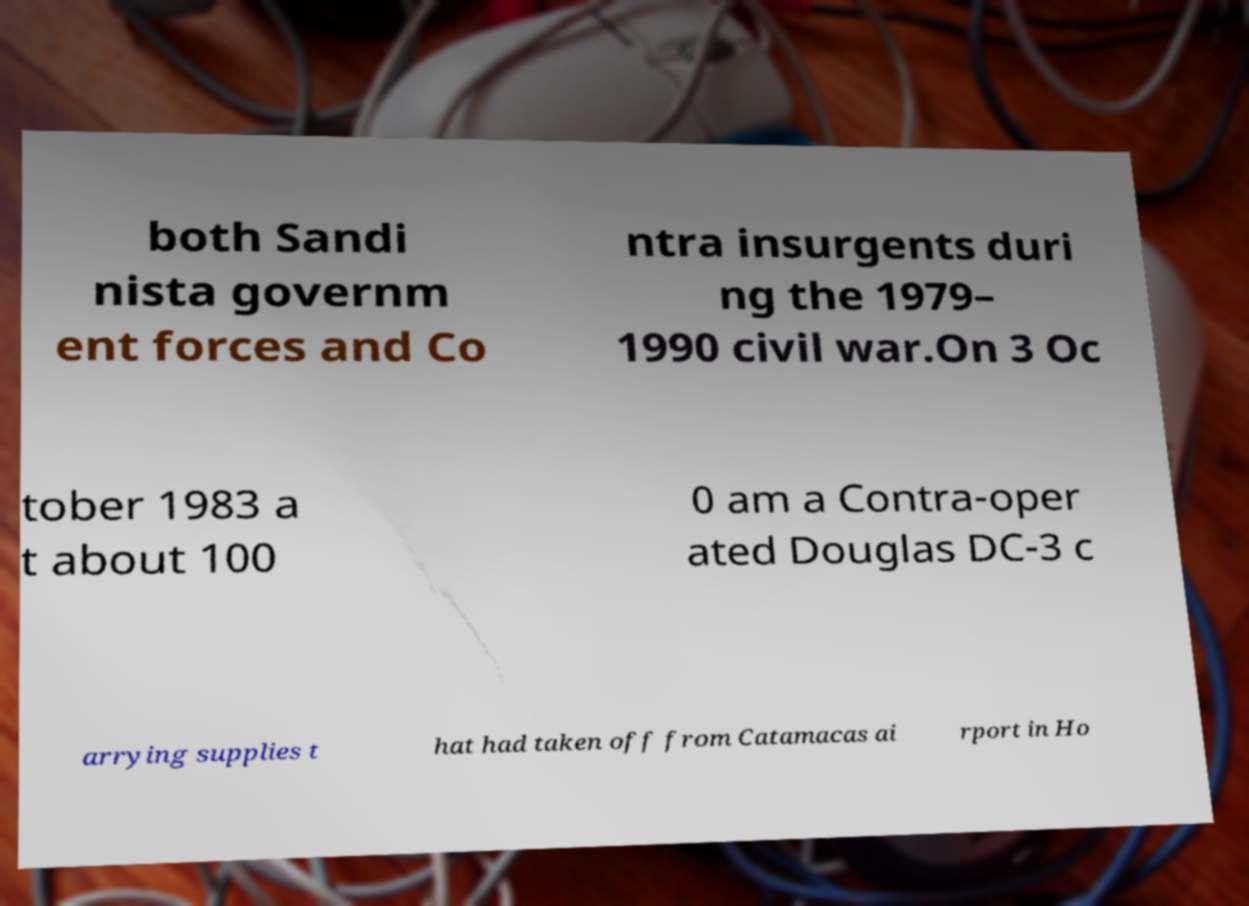Please identify and transcribe the text found in this image. both Sandi nista governm ent forces and Co ntra insurgents duri ng the 1979– 1990 civil war.On 3 Oc tober 1983 a t about 100 0 am a Contra-oper ated Douglas DC-3 c arrying supplies t hat had taken off from Catamacas ai rport in Ho 